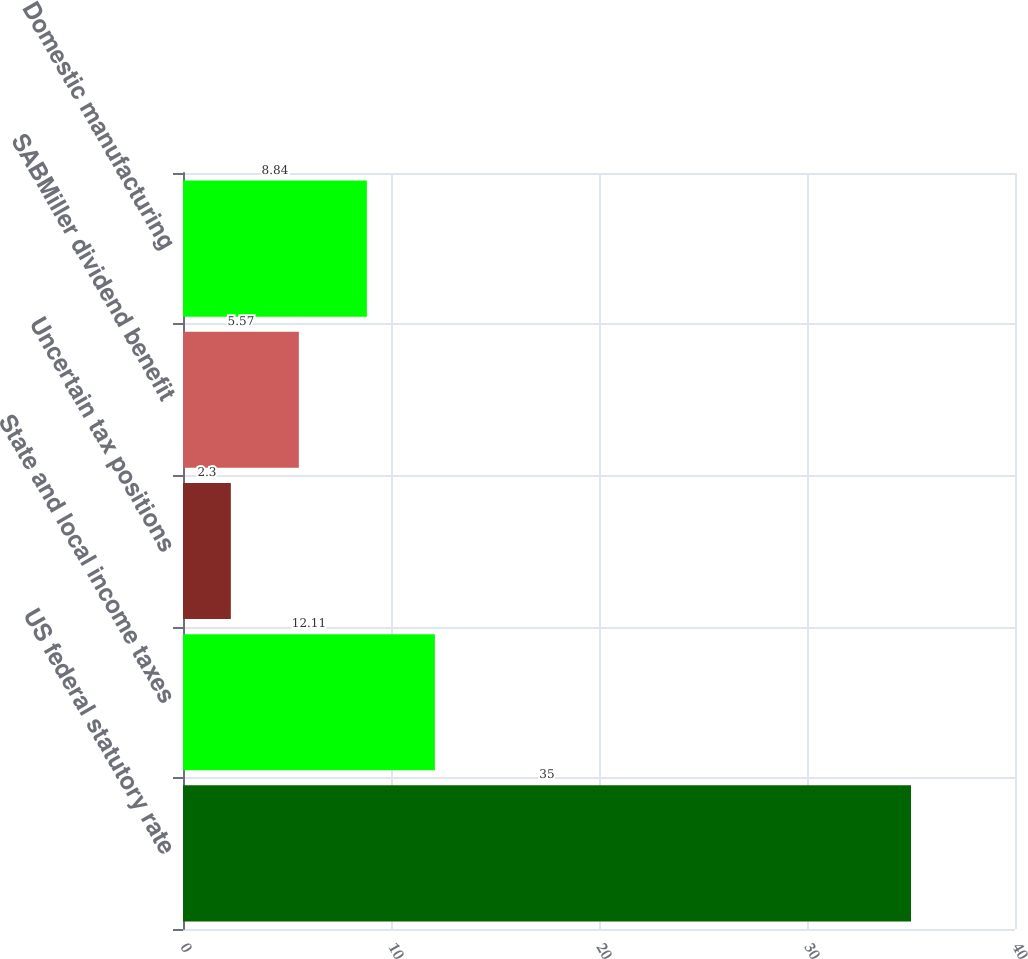Convert chart to OTSL. <chart><loc_0><loc_0><loc_500><loc_500><bar_chart><fcel>US federal statutory rate<fcel>State and local income taxes<fcel>Uncertain tax positions<fcel>SABMiller dividend benefit<fcel>Domestic manufacturing<nl><fcel>35<fcel>12.11<fcel>2.3<fcel>5.57<fcel>8.84<nl></chart> 